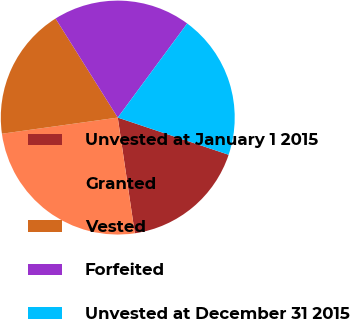Convert chart. <chart><loc_0><loc_0><loc_500><loc_500><pie_chart><fcel>Unvested at January 1 2015<fcel>Granted<fcel>Vested<fcel>Forfeited<fcel>Unvested at December 31 2015<nl><fcel>17.52%<fcel>25.12%<fcel>18.28%<fcel>19.04%<fcel>20.03%<nl></chart> 